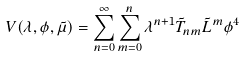<formula> <loc_0><loc_0><loc_500><loc_500>V ( \lambda , \phi , \tilde { \mu } ) = \sum _ { n = 0 } ^ { \infty } \sum _ { m = 0 } ^ { n } \lambda ^ { n + 1 } \tilde { T } _ { n m } \tilde { L } ^ { m } \phi ^ { 4 }</formula> 